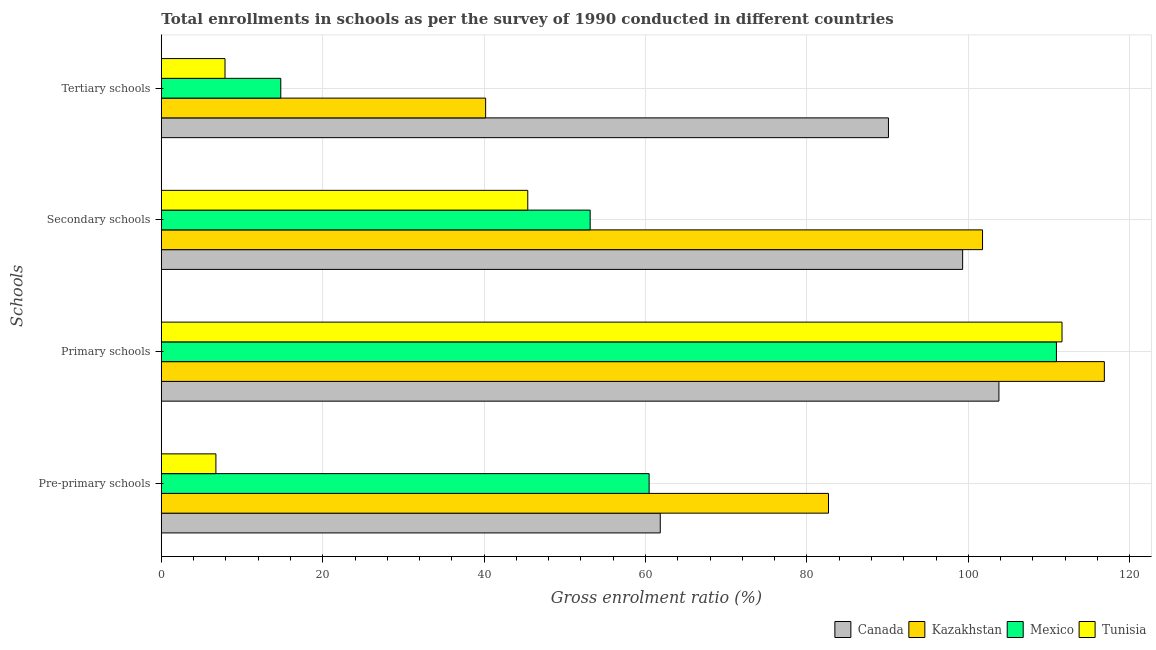How many groups of bars are there?
Offer a very short reply. 4. Are the number of bars per tick equal to the number of legend labels?
Your answer should be compact. Yes. Are the number of bars on each tick of the Y-axis equal?
Your response must be concise. Yes. What is the label of the 4th group of bars from the top?
Keep it short and to the point. Pre-primary schools. What is the gross enrolment ratio in secondary schools in Mexico?
Provide a succinct answer. 53.14. Across all countries, what is the maximum gross enrolment ratio in primary schools?
Provide a short and direct response. 116.85. Across all countries, what is the minimum gross enrolment ratio in tertiary schools?
Offer a terse response. 7.89. In which country was the gross enrolment ratio in primary schools maximum?
Keep it short and to the point. Kazakhstan. What is the total gross enrolment ratio in primary schools in the graph?
Give a very brief answer. 443.15. What is the difference between the gross enrolment ratio in primary schools in Canada and that in Mexico?
Offer a very short reply. -7.13. What is the difference between the gross enrolment ratio in secondary schools in Kazakhstan and the gross enrolment ratio in tertiary schools in Tunisia?
Give a very brief answer. 93.86. What is the average gross enrolment ratio in primary schools per country?
Offer a very short reply. 110.79. What is the difference between the gross enrolment ratio in primary schools and gross enrolment ratio in pre-primary schools in Canada?
Give a very brief answer. 41.96. In how many countries, is the gross enrolment ratio in secondary schools greater than 80 %?
Offer a terse response. 2. What is the ratio of the gross enrolment ratio in pre-primary schools in Tunisia to that in Mexico?
Your answer should be very brief. 0.11. Is the gross enrolment ratio in pre-primary schools in Canada less than that in Mexico?
Make the answer very short. No. Is the difference between the gross enrolment ratio in primary schools in Tunisia and Kazakhstan greater than the difference between the gross enrolment ratio in pre-primary schools in Tunisia and Kazakhstan?
Give a very brief answer. Yes. What is the difference between the highest and the second highest gross enrolment ratio in pre-primary schools?
Offer a terse response. 20.84. What is the difference between the highest and the lowest gross enrolment ratio in tertiary schools?
Make the answer very short. 82.2. Is the sum of the gross enrolment ratio in tertiary schools in Tunisia and Mexico greater than the maximum gross enrolment ratio in secondary schools across all countries?
Keep it short and to the point. No. Is it the case that in every country, the sum of the gross enrolment ratio in secondary schools and gross enrolment ratio in tertiary schools is greater than the sum of gross enrolment ratio in primary schools and gross enrolment ratio in pre-primary schools?
Your answer should be very brief. No. What does the 1st bar from the top in Secondary schools represents?
Keep it short and to the point. Tunisia. What does the 2nd bar from the bottom in Primary schools represents?
Your response must be concise. Kazakhstan. Are all the bars in the graph horizontal?
Your response must be concise. Yes. How many countries are there in the graph?
Offer a very short reply. 4. Where does the legend appear in the graph?
Provide a short and direct response. Bottom right. How many legend labels are there?
Provide a succinct answer. 4. What is the title of the graph?
Offer a very short reply. Total enrollments in schools as per the survey of 1990 conducted in different countries. Does "Sub-Saharan Africa (developing only)" appear as one of the legend labels in the graph?
Your answer should be compact. No. What is the label or title of the Y-axis?
Offer a very short reply. Schools. What is the Gross enrolment ratio (%) of Canada in Pre-primary schools?
Make the answer very short. 61.82. What is the Gross enrolment ratio (%) of Kazakhstan in Pre-primary schools?
Your answer should be very brief. 82.67. What is the Gross enrolment ratio (%) in Mexico in Pre-primary schools?
Give a very brief answer. 60.44. What is the Gross enrolment ratio (%) in Tunisia in Pre-primary schools?
Offer a terse response. 6.76. What is the Gross enrolment ratio (%) in Canada in Primary schools?
Give a very brief answer. 103.78. What is the Gross enrolment ratio (%) in Kazakhstan in Primary schools?
Provide a succinct answer. 116.85. What is the Gross enrolment ratio (%) in Mexico in Primary schools?
Give a very brief answer. 110.91. What is the Gross enrolment ratio (%) in Tunisia in Primary schools?
Provide a short and direct response. 111.6. What is the Gross enrolment ratio (%) of Canada in Secondary schools?
Offer a very short reply. 99.29. What is the Gross enrolment ratio (%) of Kazakhstan in Secondary schools?
Your response must be concise. 101.75. What is the Gross enrolment ratio (%) of Mexico in Secondary schools?
Give a very brief answer. 53.14. What is the Gross enrolment ratio (%) in Tunisia in Secondary schools?
Offer a very short reply. 45.4. What is the Gross enrolment ratio (%) of Canada in Tertiary schools?
Provide a short and direct response. 90.1. What is the Gross enrolment ratio (%) of Kazakhstan in Tertiary schools?
Make the answer very short. 40.19. What is the Gross enrolment ratio (%) of Mexico in Tertiary schools?
Your answer should be very brief. 14.8. What is the Gross enrolment ratio (%) in Tunisia in Tertiary schools?
Your answer should be very brief. 7.89. Across all Schools, what is the maximum Gross enrolment ratio (%) of Canada?
Provide a short and direct response. 103.78. Across all Schools, what is the maximum Gross enrolment ratio (%) in Kazakhstan?
Provide a short and direct response. 116.85. Across all Schools, what is the maximum Gross enrolment ratio (%) of Mexico?
Your response must be concise. 110.91. Across all Schools, what is the maximum Gross enrolment ratio (%) in Tunisia?
Your answer should be compact. 111.6. Across all Schools, what is the minimum Gross enrolment ratio (%) of Canada?
Provide a short and direct response. 61.82. Across all Schools, what is the minimum Gross enrolment ratio (%) in Kazakhstan?
Your response must be concise. 40.19. Across all Schools, what is the minimum Gross enrolment ratio (%) in Mexico?
Offer a very short reply. 14.8. Across all Schools, what is the minimum Gross enrolment ratio (%) in Tunisia?
Offer a very short reply. 6.76. What is the total Gross enrolment ratio (%) in Canada in the graph?
Provide a succinct answer. 355. What is the total Gross enrolment ratio (%) of Kazakhstan in the graph?
Your response must be concise. 341.46. What is the total Gross enrolment ratio (%) in Mexico in the graph?
Provide a short and direct response. 239.29. What is the total Gross enrolment ratio (%) in Tunisia in the graph?
Offer a terse response. 171.67. What is the difference between the Gross enrolment ratio (%) of Canada in Pre-primary schools and that in Primary schools?
Offer a very short reply. -41.96. What is the difference between the Gross enrolment ratio (%) of Kazakhstan in Pre-primary schools and that in Primary schools?
Your answer should be compact. -34.18. What is the difference between the Gross enrolment ratio (%) of Mexico in Pre-primary schools and that in Primary schools?
Keep it short and to the point. -50.47. What is the difference between the Gross enrolment ratio (%) in Tunisia in Pre-primary schools and that in Primary schools?
Give a very brief answer. -104.84. What is the difference between the Gross enrolment ratio (%) in Canada in Pre-primary schools and that in Secondary schools?
Give a very brief answer. -37.46. What is the difference between the Gross enrolment ratio (%) in Kazakhstan in Pre-primary schools and that in Secondary schools?
Offer a terse response. -19.09. What is the difference between the Gross enrolment ratio (%) of Mexico in Pre-primary schools and that in Secondary schools?
Give a very brief answer. 7.31. What is the difference between the Gross enrolment ratio (%) in Tunisia in Pre-primary schools and that in Secondary schools?
Provide a succinct answer. -38.64. What is the difference between the Gross enrolment ratio (%) of Canada in Pre-primary schools and that in Tertiary schools?
Offer a terse response. -28.27. What is the difference between the Gross enrolment ratio (%) in Kazakhstan in Pre-primary schools and that in Tertiary schools?
Your answer should be very brief. 42.48. What is the difference between the Gross enrolment ratio (%) of Mexico in Pre-primary schools and that in Tertiary schools?
Provide a succinct answer. 45.64. What is the difference between the Gross enrolment ratio (%) of Tunisia in Pre-primary schools and that in Tertiary schools?
Keep it short and to the point. -1.13. What is the difference between the Gross enrolment ratio (%) of Canada in Primary schools and that in Secondary schools?
Give a very brief answer. 4.5. What is the difference between the Gross enrolment ratio (%) in Kazakhstan in Primary schools and that in Secondary schools?
Provide a succinct answer. 15.09. What is the difference between the Gross enrolment ratio (%) of Mexico in Primary schools and that in Secondary schools?
Your answer should be very brief. 57.77. What is the difference between the Gross enrolment ratio (%) of Tunisia in Primary schools and that in Secondary schools?
Ensure brevity in your answer.  66.2. What is the difference between the Gross enrolment ratio (%) in Canada in Primary schools and that in Tertiary schools?
Offer a very short reply. 13.69. What is the difference between the Gross enrolment ratio (%) in Kazakhstan in Primary schools and that in Tertiary schools?
Make the answer very short. 76.66. What is the difference between the Gross enrolment ratio (%) in Mexico in Primary schools and that in Tertiary schools?
Give a very brief answer. 96.11. What is the difference between the Gross enrolment ratio (%) in Tunisia in Primary schools and that in Tertiary schools?
Provide a succinct answer. 103.71. What is the difference between the Gross enrolment ratio (%) of Canada in Secondary schools and that in Tertiary schools?
Provide a succinct answer. 9.19. What is the difference between the Gross enrolment ratio (%) in Kazakhstan in Secondary schools and that in Tertiary schools?
Give a very brief answer. 61.57. What is the difference between the Gross enrolment ratio (%) in Mexico in Secondary schools and that in Tertiary schools?
Make the answer very short. 38.34. What is the difference between the Gross enrolment ratio (%) of Tunisia in Secondary schools and that in Tertiary schools?
Provide a short and direct response. 37.51. What is the difference between the Gross enrolment ratio (%) in Canada in Pre-primary schools and the Gross enrolment ratio (%) in Kazakhstan in Primary schools?
Offer a very short reply. -55.02. What is the difference between the Gross enrolment ratio (%) in Canada in Pre-primary schools and the Gross enrolment ratio (%) in Mexico in Primary schools?
Your response must be concise. -49.09. What is the difference between the Gross enrolment ratio (%) of Canada in Pre-primary schools and the Gross enrolment ratio (%) of Tunisia in Primary schools?
Keep it short and to the point. -49.78. What is the difference between the Gross enrolment ratio (%) of Kazakhstan in Pre-primary schools and the Gross enrolment ratio (%) of Mexico in Primary schools?
Keep it short and to the point. -28.24. What is the difference between the Gross enrolment ratio (%) of Kazakhstan in Pre-primary schools and the Gross enrolment ratio (%) of Tunisia in Primary schools?
Offer a very short reply. -28.94. What is the difference between the Gross enrolment ratio (%) of Mexico in Pre-primary schools and the Gross enrolment ratio (%) of Tunisia in Primary schools?
Provide a short and direct response. -51.16. What is the difference between the Gross enrolment ratio (%) of Canada in Pre-primary schools and the Gross enrolment ratio (%) of Kazakhstan in Secondary schools?
Offer a very short reply. -39.93. What is the difference between the Gross enrolment ratio (%) of Canada in Pre-primary schools and the Gross enrolment ratio (%) of Mexico in Secondary schools?
Your response must be concise. 8.69. What is the difference between the Gross enrolment ratio (%) in Canada in Pre-primary schools and the Gross enrolment ratio (%) in Tunisia in Secondary schools?
Ensure brevity in your answer.  16.42. What is the difference between the Gross enrolment ratio (%) of Kazakhstan in Pre-primary schools and the Gross enrolment ratio (%) of Mexico in Secondary schools?
Your response must be concise. 29.53. What is the difference between the Gross enrolment ratio (%) in Kazakhstan in Pre-primary schools and the Gross enrolment ratio (%) in Tunisia in Secondary schools?
Your answer should be very brief. 37.26. What is the difference between the Gross enrolment ratio (%) in Mexico in Pre-primary schools and the Gross enrolment ratio (%) in Tunisia in Secondary schools?
Your answer should be very brief. 15.04. What is the difference between the Gross enrolment ratio (%) in Canada in Pre-primary schools and the Gross enrolment ratio (%) in Kazakhstan in Tertiary schools?
Provide a short and direct response. 21.64. What is the difference between the Gross enrolment ratio (%) of Canada in Pre-primary schools and the Gross enrolment ratio (%) of Mexico in Tertiary schools?
Offer a very short reply. 47.02. What is the difference between the Gross enrolment ratio (%) of Canada in Pre-primary schools and the Gross enrolment ratio (%) of Tunisia in Tertiary schools?
Keep it short and to the point. 53.93. What is the difference between the Gross enrolment ratio (%) of Kazakhstan in Pre-primary schools and the Gross enrolment ratio (%) of Mexico in Tertiary schools?
Make the answer very short. 67.87. What is the difference between the Gross enrolment ratio (%) of Kazakhstan in Pre-primary schools and the Gross enrolment ratio (%) of Tunisia in Tertiary schools?
Ensure brevity in your answer.  74.78. What is the difference between the Gross enrolment ratio (%) of Mexico in Pre-primary schools and the Gross enrolment ratio (%) of Tunisia in Tertiary schools?
Ensure brevity in your answer.  52.55. What is the difference between the Gross enrolment ratio (%) in Canada in Primary schools and the Gross enrolment ratio (%) in Kazakhstan in Secondary schools?
Your answer should be very brief. 2.03. What is the difference between the Gross enrolment ratio (%) of Canada in Primary schools and the Gross enrolment ratio (%) of Mexico in Secondary schools?
Ensure brevity in your answer.  50.65. What is the difference between the Gross enrolment ratio (%) of Canada in Primary schools and the Gross enrolment ratio (%) of Tunisia in Secondary schools?
Keep it short and to the point. 58.38. What is the difference between the Gross enrolment ratio (%) in Kazakhstan in Primary schools and the Gross enrolment ratio (%) in Mexico in Secondary schools?
Provide a short and direct response. 63.71. What is the difference between the Gross enrolment ratio (%) of Kazakhstan in Primary schools and the Gross enrolment ratio (%) of Tunisia in Secondary schools?
Your answer should be very brief. 71.44. What is the difference between the Gross enrolment ratio (%) in Mexico in Primary schools and the Gross enrolment ratio (%) in Tunisia in Secondary schools?
Your answer should be compact. 65.51. What is the difference between the Gross enrolment ratio (%) in Canada in Primary schools and the Gross enrolment ratio (%) in Kazakhstan in Tertiary schools?
Give a very brief answer. 63.6. What is the difference between the Gross enrolment ratio (%) of Canada in Primary schools and the Gross enrolment ratio (%) of Mexico in Tertiary schools?
Ensure brevity in your answer.  88.98. What is the difference between the Gross enrolment ratio (%) of Canada in Primary schools and the Gross enrolment ratio (%) of Tunisia in Tertiary schools?
Keep it short and to the point. 95.89. What is the difference between the Gross enrolment ratio (%) of Kazakhstan in Primary schools and the Gross enrolment ratio (%) of Mexico in Tertiary schools?
Offer a very short reply. 102.04. What is the difference between the Gross enrolment ratio (%) in Kazakhstan in Primary schools and the Gross enrolment ratio (%) in Tunisia in Tertiary schools?
Offer a very short reply. 108.95. What is the difference between the Gross enrolment ratio (%) of Mexico in Primary schools and the Gross enrolment ratio (%) of Tunisia in Tertiary schools?
Offer a very short reply. 103.02. What is the difference between the Gross enrolment ratio (%) of Canada in Secondary schools and the Gross enrolment ratio (%) of Kazakhstan in Tertiary schools?
Provide a succinct answer. 59.1. What is the difference between the Gross enrolment ratio (%) in Canada in Secondary schools and the Gross enrolment ratio (%) in Mexico in Tertiary schools?
Provide a short and direct response. 84.49. What is the difference between the Gross enrolment ratio (%) in Canada in Secondary schools and the Gross enrolment ratio (%) in Tunisia in Tertiary schools?
Provide a succinct answer. 91.4. What is the difference between the Gross enrolment ratio (%) in Kazakhstan in Secondary schools and the Gross enrolment ratio (%) in Mexico in Tertiary schools?
Your response must be concise. 86.95. What is the difference between the Gross enrolment ratio (%) of Kazakhstan in Secondary schools and the Gross enrolment ratio (%) of Tunisia in Tertiary schools?
Keep it short and to the point. 93.86. What is the difference between the Gross enrolment ratio (%) of Mexico in Secondary schools and the Gross enrolment ratio (%) of Tunisia in Tertiary schools?
Ensure brevity in your answer.  45.25. What is the average Gross enrolment ratio (%) of Canada per Schools?
Keep it short and to the point. 88.75. What is the average Gross enrolment ratio (%) in Kazakhstan per Schools?
Offer a terse response. 85.36. What is the average Gross enrolment ratio (%) of Mexico per Schools?
Offer a terse response. 59.82. What is the average Gross enrolment ratio (%) of Tunisia per Schools?
Your response must be concise. 42.92. What is the difference between the Gross enrolment ratio (%) in Canada and Gross enrolment ratio (%) in Kazakhstan in Pre-primary schools?
Your answer should be very brief. -20.84. What is the difference between the Gross enrolment ratio (%) of Canada and Gross enrolment ratio (%) of Mexico in Pre-primary schools?
Offer a terse response. 1.38. What is the difference between the Gross enrolment ratio (%) in Canada and Gross enrolment ratio (%) in Tunisia in Pre-primary schools?
Your response must be concise. 55.06. What is the difference between the Gross enrolment ratio (%) in Kazakhstan and Gross enrolment ratio (%) in Mexico in Pre-primary schools?
Your response must be concise. 22.22. What is the difference between the Gross enrolment ratio (%) of Kazakhstan and Gross enrolment ratio (%) of Tunisia in Pre-primary schools?
Your response must be concise. 75.9. What is the difference between the Gross enrolment ratio (%) in Mexico and Gross enrolment ratio (%) in Tunisia in Pre-primary schools?
Your response must be concise. 53.68. What is the difference between the Gross enrolment ratio (%) in Canada and Gross enrolment ratio (%) in Kazakhstan in Primary schools?
Make the answer very short. -13.06. What is the difference between the Gross enrolment ratio (%) of Canada and Gross enrolment ratio (%) of Mexico in Primary schools?
Your answer should be very brief. -7.13. What is the difference between the Gross enrolment ratio (%) of Canada and Gross enrolment ratio (%) of Tunisia in Primary schools?
Your answer should be very brief. -7.82. What is the difference between the Gross enrolment ratio (%) of Kazakhstan and Gross enrolment ratio (%) of Mexico in Primary schools?
Offer a very short reply. 5.94. What is the difference between the Gross enrolment ratio (%) in Kazakhstan and Gross enrolment ratio (%) in Tunisia in Primary schools?
Your response must be concise. 5.24. What is the difference between the Gross enrolment ratio (%) of Mexico and Gross enrolment ratio (%) of Tunisia in Primary schools?
Offer a terse response. -0.69. What is the difference between the Gross enrolment ratio (%) of Canada and Gross enrolment ratio (%) of Kazakhstan in Secondary schools?
Your response must be concise. -2.46. What is the difference between the Gross enrolment ratio (%) of Canada and Gross enrolment ratio (%) of Mexico in Secondary schools?
Give a very brief answer. 46.15. What is the difference between the Gross enrolment ratio (%) of Canada and Gross enrolment ratio (%) of Tunisia in Secondary schools?
Make the answer very short. 53.88. What is the difference between the Gross enrolment ratio (%) of Kazakhstan and Gross enrolment ratio (%) of Mexico in Secondary schools?
Your response must be concise. 48.62. What is the difference between the Gross enrolment ratio (%) of Kazakhstan and Gross enrolment ratio (%) of Tunisia in Secondary schools?
Offer a very short reply. 56.35. What is the difference between the Gross enrolment ratio (%) in Mexico and Gross enrolment ratio (%) in Tunisia in Secondary schools?
Ensure brevity in your answer.  7.73. What is the difference between the Gross enrolment ratio (%) in Canada and Gross enrolment ratio (%) in Kazakhstan in Tertiary schools?
Give a very brief answer. 49.91. What is the difference between the Gross enrolment ratio (%) in Canada and Gross enrolment ratio (%) in Mexico in Tertiary schools?
Provide a short and direct response. 75.29. What is the difference between the Gross enrolment ratio (%) in Canada and Gross enrolment ratio (%) in Tunisia in Tertiary schools?
Ensure brevity in your answer.  82.2. What is the difference between the Gross enrolment ratio (%) in Kazakhstan and Gross enrolment ratio (%) in Mexico in Tertiary schools?
Your answer should be compact. 25.38. What is the difference between the Gross enrolment ratio (%) in Kazakhstan and Gross enrolment ratio (%) in Tunisia in Tertiary schools?
Give a very brief answer. 32.29. What is the difference between the Gross enrolment ratio (%) of Mexico and Gross enrolment ratio (%) of Tunisia in Tertiary schools?
Offer a terse response. 6.91. What is the ratio of the Gross enrolment ratio (%) in Canada in Pre-primary schools to that in Primary schools?
Provide a succinct answer. 0.6. What is the ratio of the Gross enrolment ratio (%) in Kazakhstan in Pre-primary schools to that in Primary schools?
Ensure brevity in your answer.  0.71. What is the ratio of the Gross enrolment ratio (%) of Mexico in Pre-primary schools to that in Primary schools?
Give a very brief answer. 0.55. What is the ratio of the Gross enrolment ratio (%) in Tunisia in Pre-primary schools to that in Primary schools?
Ensure brevity in your answer.  0.06. What is the ratio of the Gross enrolment ratio (%) of Canada in Pre-primary schools to that in Secondary schools?
Your response must be concise. 0.62. What is the ratio of the Gross enrolment ratio (%) in Kazakhstan in Pre-primary schools to that in Secondary schools?
Make the answer very short. 0.81. What is the ratio of the Gross enrolment ratio (%) of Mexico in Pre-primary schools to that in Secondary schools?
Provide a short and direct response. 1.14. What is the ratio of the Gross enrolment ratio (%) in Tunisia in Pre-primary schools to that in Secondary schools?
Ensure brevity in your answer.  0.15. What is the ratio of the Gross enrolment ratio (%) of Canada in Pre-primary schools to that in Tertiary schools?
Keep it short and to the point. 0.69. What is the ratio of the Gross enrolment ratio (%) in Kazakhstan in Pre-primary schools to that in Tertiary schools?
Provide a succinct answer. 2.06. What is the ratio of the Gross enrolment ratio (%) of Mexico in Pre-primary schools to that in Tertiary schools?
Make the answer very short. 4.08. What is the ratio of the Gross enrolment ratio (%) in Tunisia in Pre-primary schools to that in Tertiary schools?
Keep it short and to the point. 0.86. What is the ratio of the Gross enrolment ratio (%) in Canada in Primary schools to that in Secondary schools?
Provide a short and direct response. 1.05. What is the ratio of the Gross enrolment ratio (%) of Kazakhstan in Primary schools to that in Secondary schools?
Ensure brevity in your answer.  1.15. What is the ratio of the Gross enrolment ratio (%) in Mexico in Primary schools to that in Secondary schools?
Ensure brevity in your answer.  2.09. What is the ratio of the Gross enrolment ratio (%) of Tunisia in Primary schools to that in Secondary schools?
Your answer should be very brief. 2.46. What is the ratio of the Gross enrolment ratio (%) of Canada in Primary schools to that in Tertiary schools?
Your answer should be very brief. 1.15. What is the ratio of the Gross enrolment ratio (%) in Kazakhstan in Primary schools to that in Tertiary schools?
Offer a terse response. 2.91. What is the ratio of the Gross enrolment ratio (%) of Mexico in Primary schools to that in Tertiary schools?
Keep it short and to the point. 7.49. What is the ratio of the Gross enrolment ratio (%) in Tunisia in Primary schools to that in Tertiary schools?
Ensure brevity in your answer.  14.14. What is the ratio of the Gross enrolment ratio (%) of Canada in Secondary schools to that in Tertiary schools?
Give a very brief answer. 1.1. What is the ratio of the Gross enrolment ratio (%) in Kazakhstan in Secondary schools to that in Tertiary schools?
Provide a short and direct response. 2.53. What is the ratio of the Gross enrolment ratio (%) of Mexico in Secondary schools to that in Tertiary schools?
Provide a short and direct response. 3.59. What is the ratio of the Gross enrolment ratio (%) of Tunisia in Secondary schools to that in Tertiary schools?
Your answer should be compact. 5.75. What is the difference between the highest and the second highest Gross enrolment ratio (%) of Canada?
Provide a succinct answer. 4.5. What is the difference between the highest and the second highest Gross enrolment ratio (%) in Kazakhstan?
Keep it short and to the point. 15.09. What is the difference between the highest and the second highest Gross enrolment ratio (%) of Mexico?
Your response must be concise. 50.47. What is the difference between the highest and the second highest Gross enrolment ratio (%) in Tunisia?
Ensure brevity in your answer.  66.2. What is the difference between the highest and the lowest Gross enrolment ratio (%) in Canada?
Keep it short and to the point. 41.96. What is the difference between the highest and the lowest Gross enrolment ratio (%) in Kazakhstan?
Ensure brevity in your answer.  76.66. What is the difference between the highest and the lowest Gross enrolment ratio (%) in Mexico?
Your answer should be very brief. 96.11. What is the difference between the highest and the lowest Gross enrolment ratio (%) of Tunisia?
Keep it short and to the point. 104.84. 